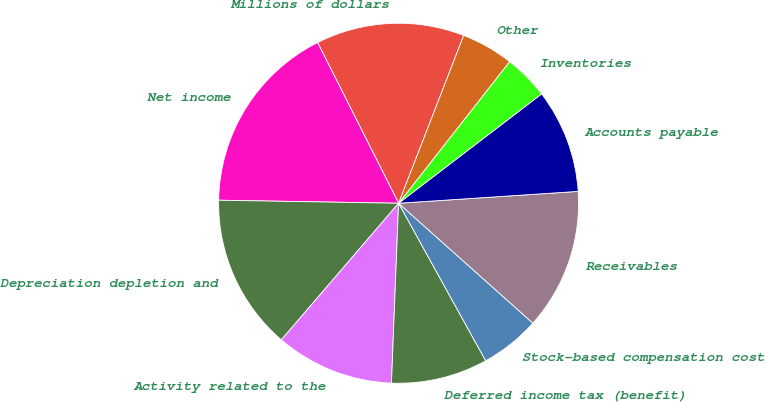<chart> <loc_0><loc_0><loc_500><loc_500><pie_chart><fcel>Millions of dollars<fcel>Net income<fcel>Depreciation depletion and<fcel>Activity related to the<fcel>Deferred income tax (benefit)<fcel>Stock-based compensation cost<fcel>Receivables<fcel>Accounts payable<fcel>Inventories<fcel>Other<nl><fcel>13.32%<fcel>17.3%<fcel>13.98%<fcel>10.66%<fcel>8.67%<fcel>5.36%<fcel>12.65%<fcel>9.34%<fcel>4.03%<fcel>4.69%<nl></chart> 